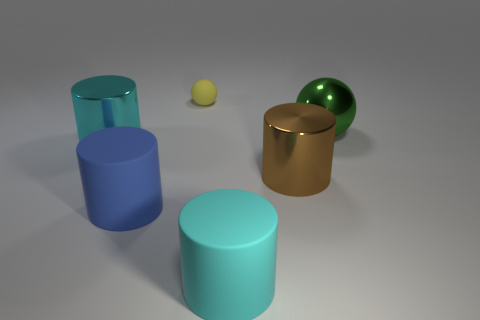Is there anything else that has the same size as the yellow matte thing?
Your answer should be compact. No. How many spheres are big matte things or tiny yellow objects?
Your answer should be very brief. 1. Is the shape of the cyan thing that is to the right of the small rubber sphere the same as the big cyan object that is to the left of the cyan matte thing?
Your answer should be compact. Yes. What is the color of the thing that is to the left of the green thing and behind the large cyan metal object?
Provide a succinct answer. Yellow. What size is the thing that is right of the cyan rubber cylinder and on the left side of the green thing?
Offer a very short reply. Large. How many other things are there of the same color as the rubber sphere?
Your answer should be compact. 0. What size is the blue matte thing on the left side of the big cyan object that is in front of the large cyan object behind the big brown thing?
Your answer should be very brief. Large. Are there any yellow matte objects behind the tiny sphere?
Your answer should be compact. No. There is a brown metallic cylinder; is it the same size as the rubber object behind the green ball?
Make the answer very short. No. How many other things are there of the same material as the big brown cylinder?
Your answer should be compact. 2. 